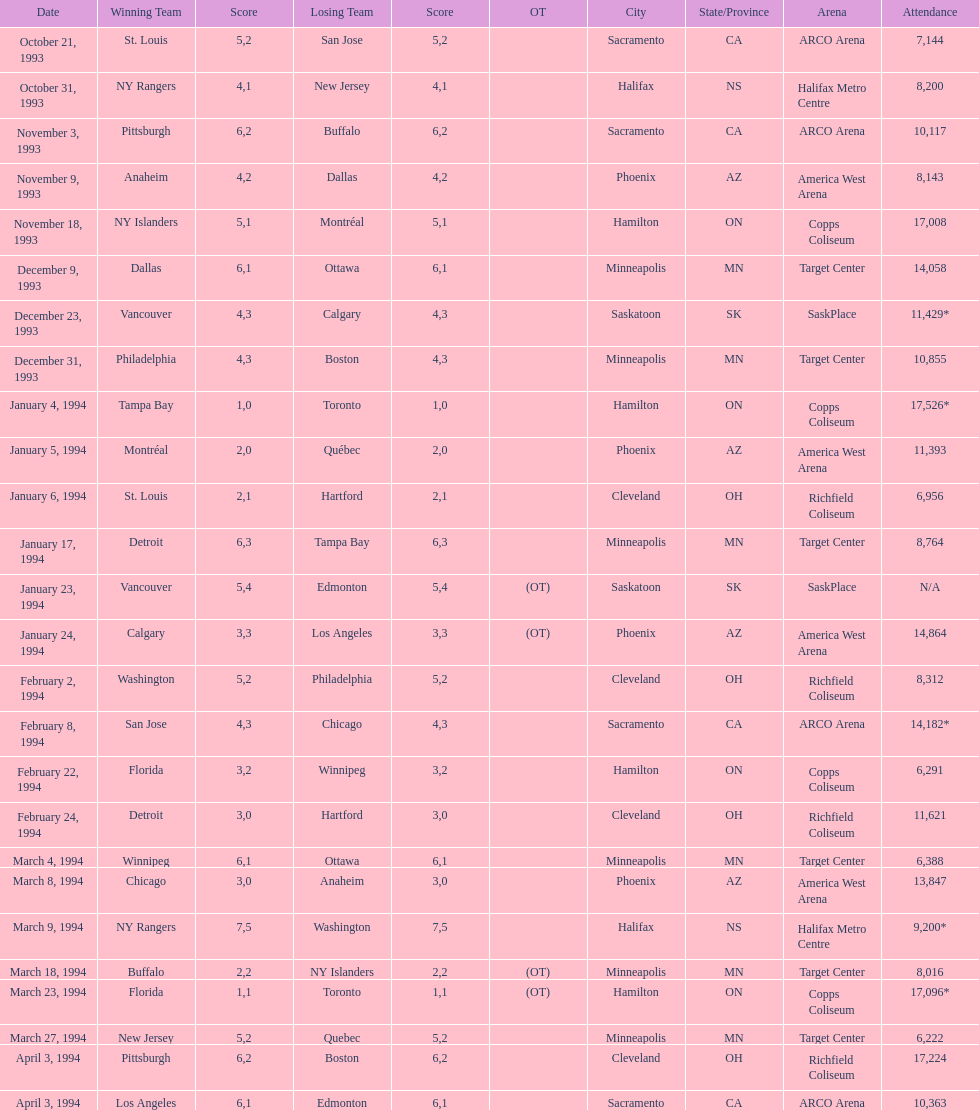Would you mind parsing the complete table? {'header': ['Date', 'Winning Team', 'Score', 'Losing Team', 'Score', 'OT', 'City', 'State/Province', 'Arena', 'Attendance'], 'rows': [['October 21, 1993', 'St. Louis', '5', 'San Jose', '2', '', 'Sacramento', 'CA', 'ARCO Arena', '7,144'], ['October 31, 1993', 'NY Rangers', '4', 'New Jersey', '1', '', 'Halifax', 'NS', 'Halifax Metro Centre', '8,200'], ['November 3, 1993', 'Pittsburgh', '6', 'Buffalo', '2', '', 'Sacramento', 'CA', 'ARCO Arena', '10,117'], ['November 9, 1993', 'Anaheim', '4', 'Dallas', '2', '', 'Phoenix', 'AZ', 'America West Arena', '8,143'], ['November 18, 1993', 'NY Islanders', '5', 'Montréal', '1', '', 'Hamilton', 'ON', 'Copps Coliseum', '17,008'], ['December 9, 1993', 'Dallas', '6', 'Ottawa', '1', '', 'Minneapolis', 'MN', 'Target Center', '14,058'], ['December 23, 1993', 'Vancouver', '4', 'Calgary', '3', '', 'Saskatoon', 'SK', 'SaskPlace', '11,429*'], ['December 31, 1993', 'Philadelphia', '4', 'Boston', '3', '', 'Minneapolis', 'MN', 'Target Center', '10,855'], ['January 4, 1994', 'Tampa Bay', '1', 'Toronto', '0', '', 'Hamilton', 'ON', 'Copps Coliseum', '17,526*'], ['January 5, 1994', 'Montréal', '2', 'Québec', '0', '', 'Phoenix', 'AZ', 'America West Arena', '11,393'], ['January 6, 1994', 'St. Louis', '2', 'Hartford', '1', '', 'Cleveland', 'OH', 'Richfield Coliseum', '6,956'], ['January 17, 1994', 'Detroit', '6', 'Tampa Bay', '3', '', 'Minneapolis', 'MN', 'Target Center', '8,764'], ['January 23, 1994', 'Vancouver', '5', 'Edmonton', '4', '(OT)', 'Saskatoon', 'SK', 'SaskPlace', 'N/A'], ['January 24, 1994', 'Calgary', '3', 'Los Angeles', '3', '(OT)', 'Phoenix', 'AZ', 'America West Arena', '14,864'], ['February 2, 1994', 'Washington', '5', 'Philadelphia', '2', '', 'Cleveland', 'OH', 'Richfield Coliseum', '8,312'], ['February 8, 1994', 'San Jose', '4', 'Chicago', '3', '', 'Sacramento', 'CA', 'ARCO Arena', '14,182*'], ['February 22, 1994', 'Florida', '3', 'Winnipeg', '2', '', 'Hamilton', 'ON', 'Copps Coliseum', '6,291'], ['February 24, 1994', 'Detroit', '3', 'Hartford', '0', '', 'Cleveland', 'OH', 'Richfield Coliseum', '11,621'], ['March 4, 1994', 'Winnipeg', '6', 'Ottawa', '1', '', 'Minneapolis', 'MN', 'Target Center', '6,388'], ['March 8, 1994', 'Chicago', '3', 'Anaheim', '0', '', 'Phoenix', 'AZ', 'America West Arena', '13,847'], ['March 9, 1994', 'NY Rangers', '7', 'Washington', '5', '', 'Halifax', 'NS', 'Halifax Metro Centre', '9,200*'], ['March 18, 1994', 'Buffalo', '2', 'NY Islanders', '2', '(OT)', 'Minneapolis', 'MN', 'Target Center', '8,016'], ['March 23, 1994', 'Florida', '1', 'Toronto', '1', '(OT)', 'Hamilton', 'ON', 'Copps Coliseum', '17,096*'], ['March 27, 1994', 'New Jersey', '5', 'Quebec', '2', '', 'Minneapolis', 'MN', 'Target Center', '6,222'], ['April 3, 1994', 'Pittsburgh', '6', 'Boston', '2', '', 'Cleveland', 'OH', 'Richfield Coliseum', '17,224'], ['April 3, 1994', 'Los Angeles', '6', 'Edmonton', '1', '', 'Sacramento', 'CA', 'ARCO Arena', '10,363']]} The game with the most attendees took place on which date? January 4, 1994. 